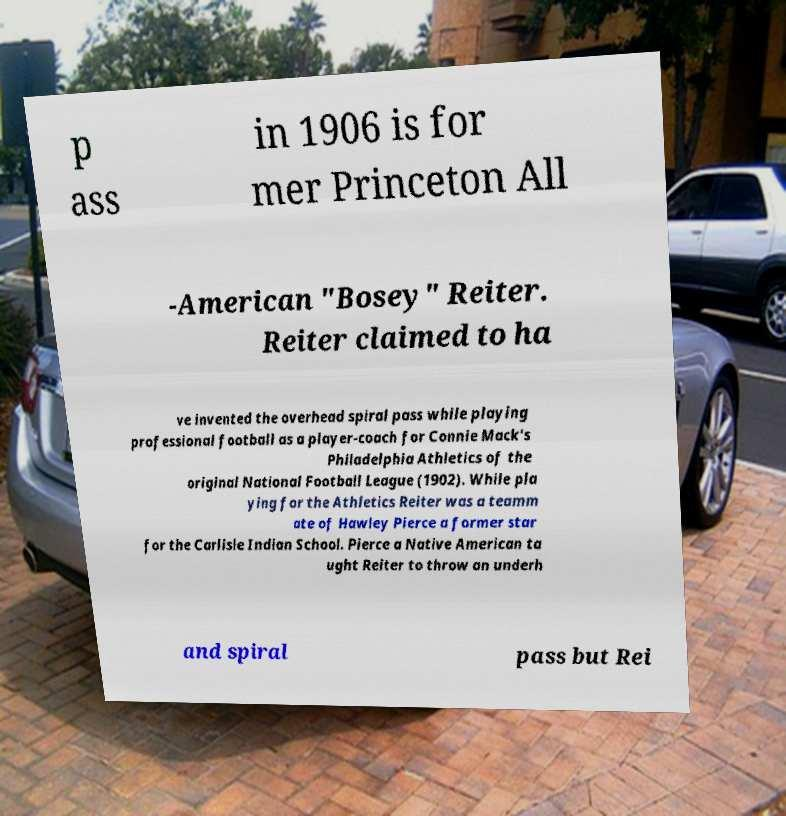Could you extract and type out the text from this image? p ass in 1906 is for mer Princeton All -American "Bosey" Reiter. Reiter claimed to ha ve invented the overhead spiral pass while playing professional football as a player-coach for Connie Mack's Philadelphia Athletics of the original National Football League (1902). While pla ying for the Athletics Reiter was a teamm ate of Hawley Pierce a former star for the Carlisle Indian School. Pierce a Native American ta ught Reiter to throw an underh and spiral pass but Rei 